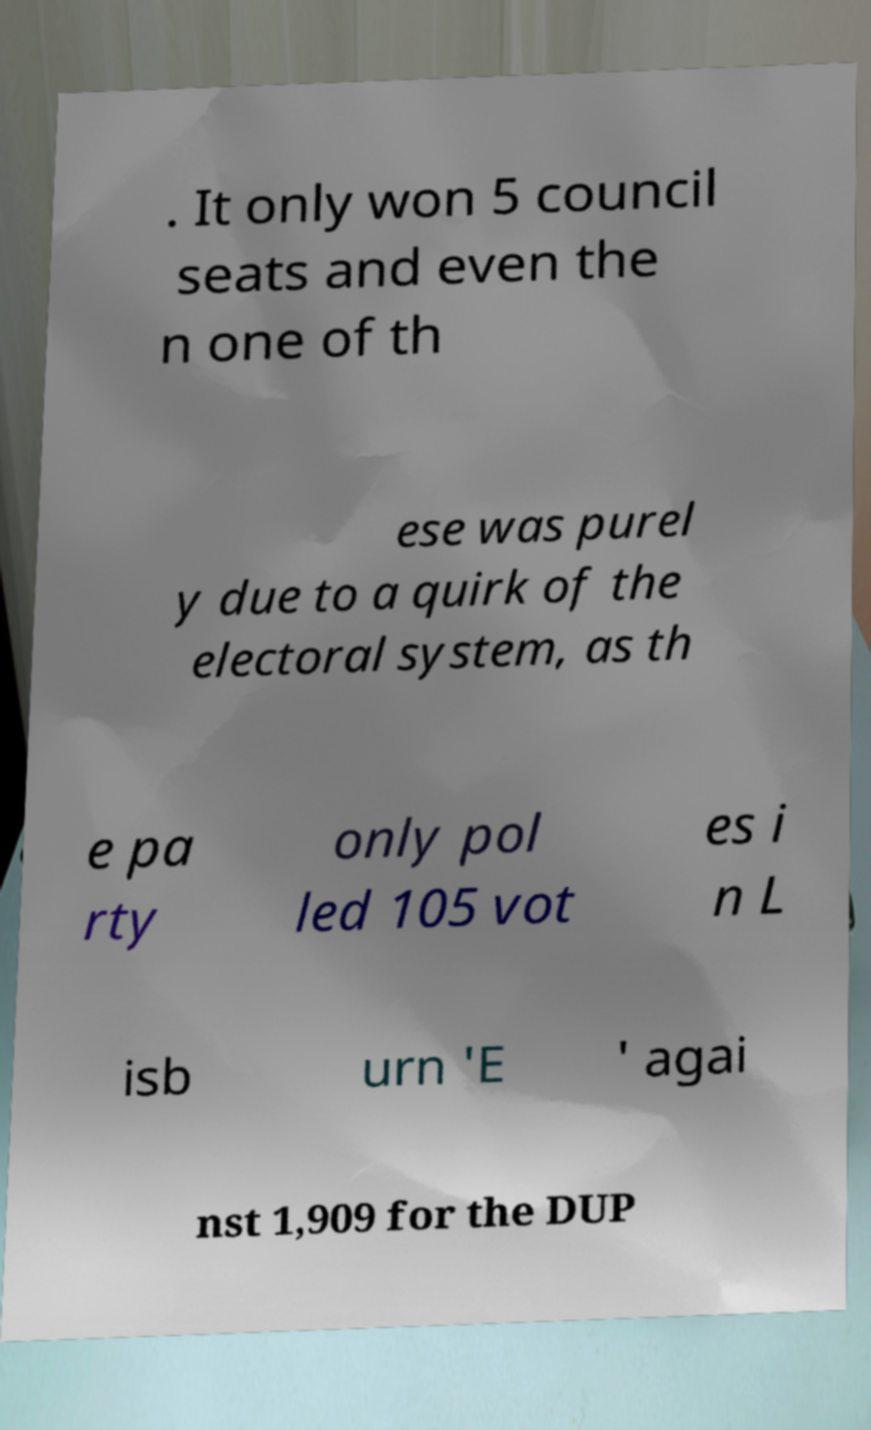There's text embedded in this image that I need extracted. Can you transcribe it verbatim? . It only won 5 council seats and even the n one of th ese was purel y due to a quirk of the electoral system, as th e pa rty only pol led 105 vot es i n L isb urn 'E ' agai nst 1,909 for the DUP 